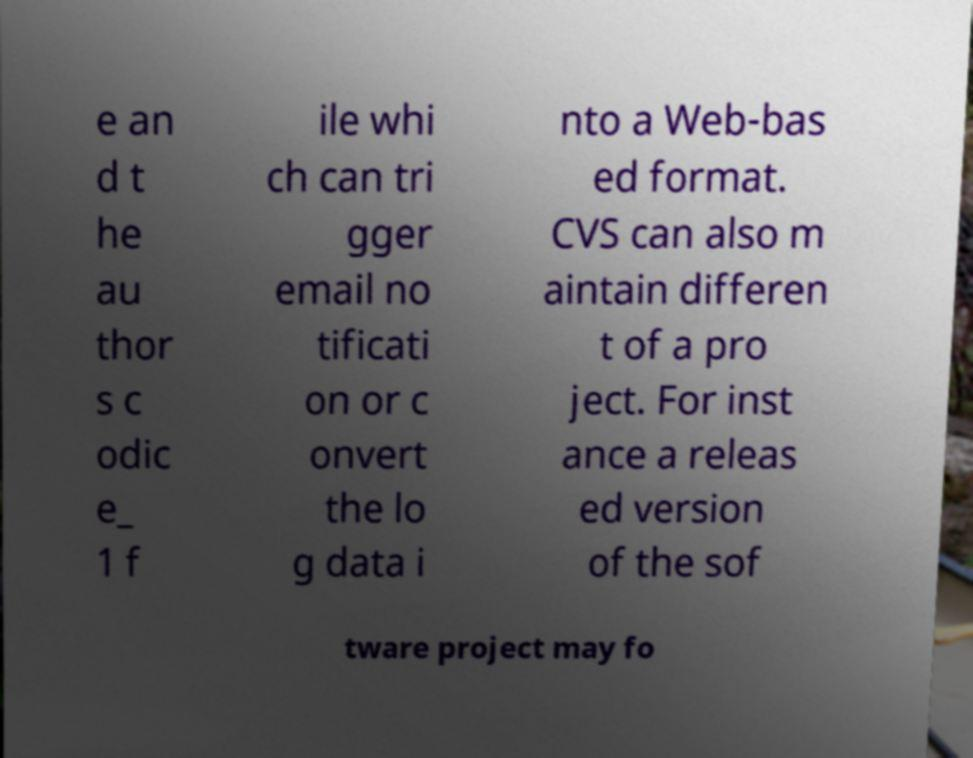Can you accurately transcribe the text from the provided image for me? e an d t he au thor s c odic e_ 1 f ile whi ch can tri gger email no tificati on or c onvert the lo g data i nto a Web-bas ed format. CVS can also m aintain differen t of a pro ject. For inst ance a releas ed version of the sof tware project may fo 